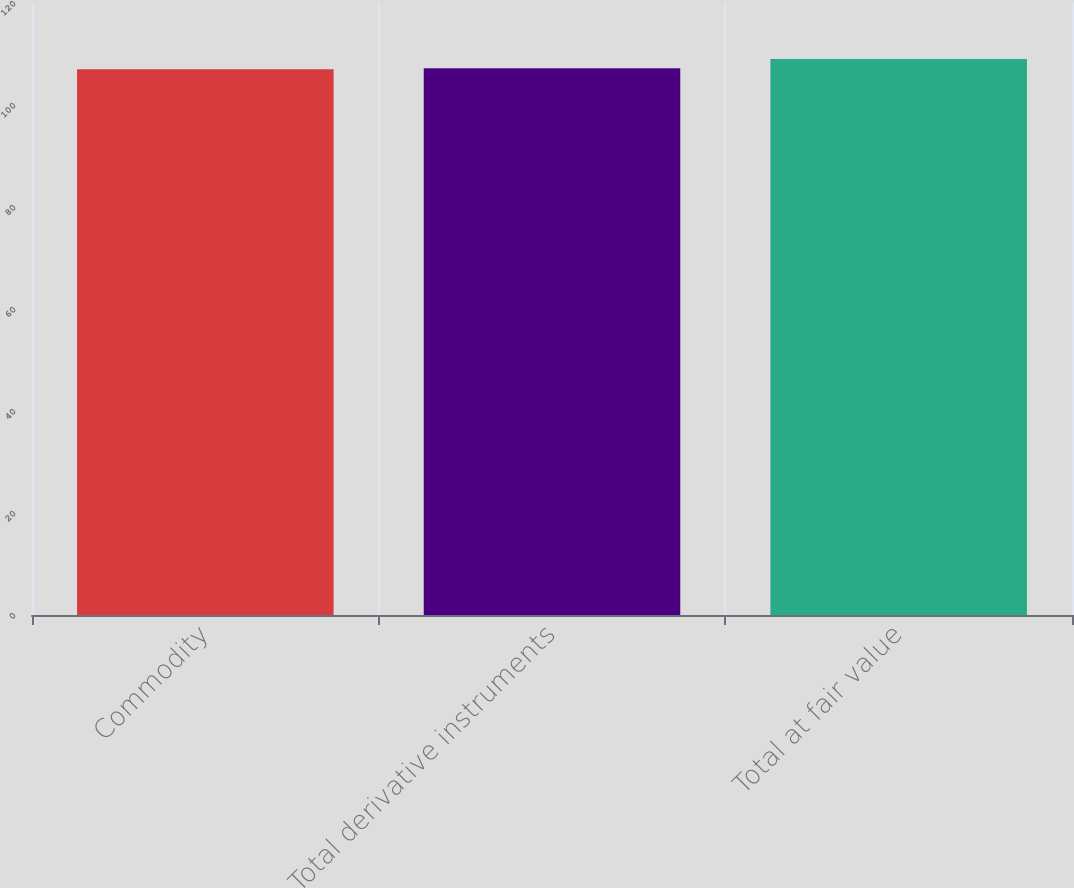<chart> <loc_0><loc_0><loc_500><loc_500><bar_chart><fcel>Commodity<fcel>Total derivative instruments<fcel>Total at fair value<nl><fcel>107<fcel>107.2<fcel>109<nl></chart> 